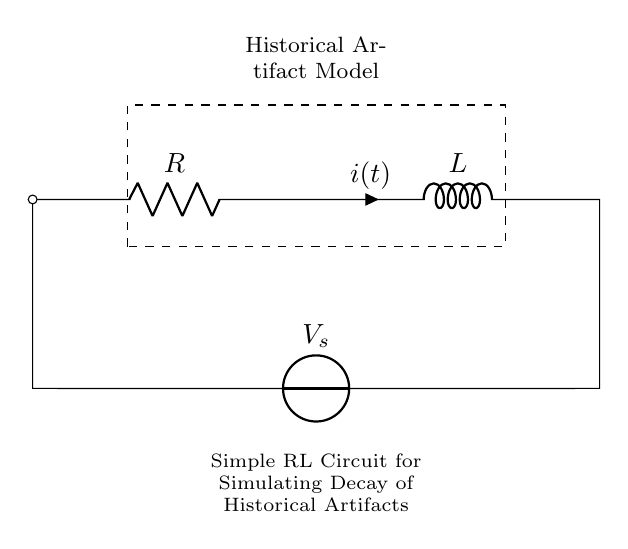What are the components in the circuit? The circuit contains a resistor and an inductor, as indicated by the symbols R and L.
Answer: resistor and inductor What direction does the current flow? The current flows from the source to the inductor through the resistor, indicated by the arrow (i>^) next to the inductor symbol.
Answer: from source to inductor What is the type of the voltage source shown? The voltage source symbol indicates it is a direct current (DC) voltage source, typical in RL circuits.
Answer: DC voltage source What is the significance of the dashed rectangle? The dashed rectangle represents the "Historical Artifact Model," indicating that the circuit simulates the decay in terms of artifact preservation.
Answer: Historical Artifact Model How does the inductor affect the circuit behavior? The inductor resists changes in current, causing a time delay in the response when the circuit is powered, resulting in an exponential decay in current over time.
Answer: Resists changes in current What happens to the current over time in an RL circuit when connected to a DC source? The current starts at zero and increases exponentially towards its maximum value, characterized by the time constant, calculated using L and R.
Answer: Exponentially increases towards maximum What represents the voltage across the inductor in this circuit? The voltage across the inductor is represented by the voltage drop across it when the current changes, given by the formula V = L(di/dt).
Answer: Inductor voltage drop 